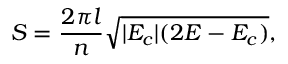<formula> <loc_0><loc_0><loc_500><loc_500>S = \frac { 2 \pi l } { n } \sqrt { | E _ { c } | ( 2 E - E _ { c } ) } ,</formula> 